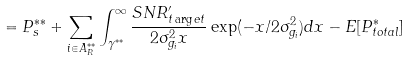Convert formula to latex. <formula><loc_0><loc_0><loc_500><loc_500>= P _ { s } ^ { * * } + \sum _ { i \in A _ { R } ^ { * * } } \int _ { \gamma ^ { * * } } ^ { \infty } \frac { S N R ^ { \prime } _ { t \arg e t } } { 2 \sigma _ { g _ { i } } ^ { 2 } x } \exp ( - x / 2 \sigma _ { g _ { i } } ^ { 2 } ) d x - E [ P ^ { * } _ { t o t a l } ]</formula> 